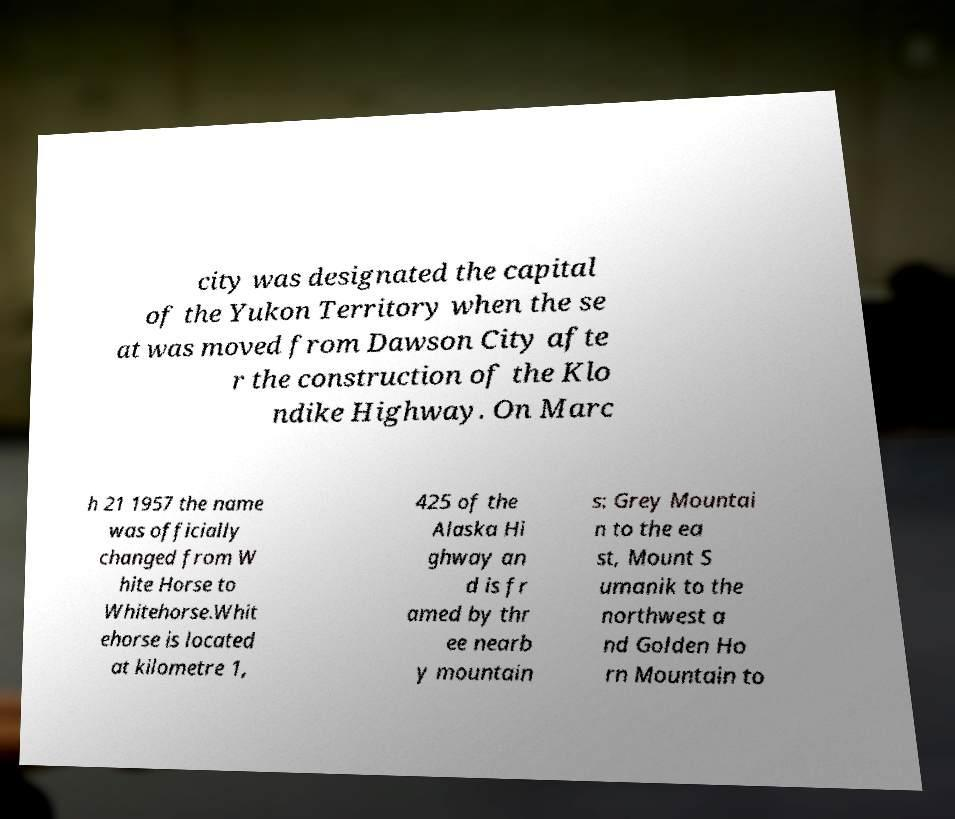Can you accurately transcribe the text from the provided image for me? city was designated the capital of the Yukon Territory when the se at was moved from Dawson City afte r the construction of the Klo ndike Highway. On Marc h 21 1957 the name was officially changed from W hite Horse to Whitehorse.Whit ehorse is located at kilometre 1, 425 of the Alaska Hi ghway an d is fr amed by thr ee nearb y mountain s: Grey Mountai n to the ea st, Mount S umanik to the northwest a nd Golden Ho rn Mountain to 